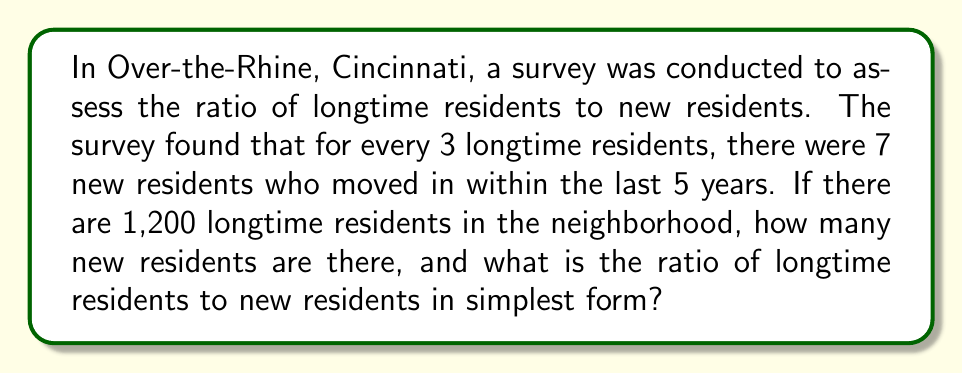Help me with this question. Let's approach this step-by-step:

1) First, we need to set up the ratio of longtime residents to new residents:
   $3 : 7$

2) We know there are 1,200 longtime residents. Let's find out how many groups of 3 longtime residents are in 1,200:
   $1200 \div 3 = 400$

3) This means there are 400 groups of the ratio 3:7

4) To find the number of new residents, we multiply 400 by 7:
   $400 \times 7 = 2800$

5) So there are 2,800 new residents

6) Now we have the total numbers for both groups:
   Longtime residents: 1,200
   New residents: 2,800

7) To express this as a ratio, we write:
   $1200 : 2800$

8) To simplify this ratio, we can divide both numbers by their greatest common divisor (GCD).
   The GCD of 1200 and 2800 is 400.

   $\frac{1200}{400} : \frac{2800}{400} = 3 : 7$

Therefore, the simplified ratio of longtime residents to new residents is 3:7.
Answer: There are 2,800 new residents, and the ratio of longtime residents to new residents in simplest form is 3:7. 